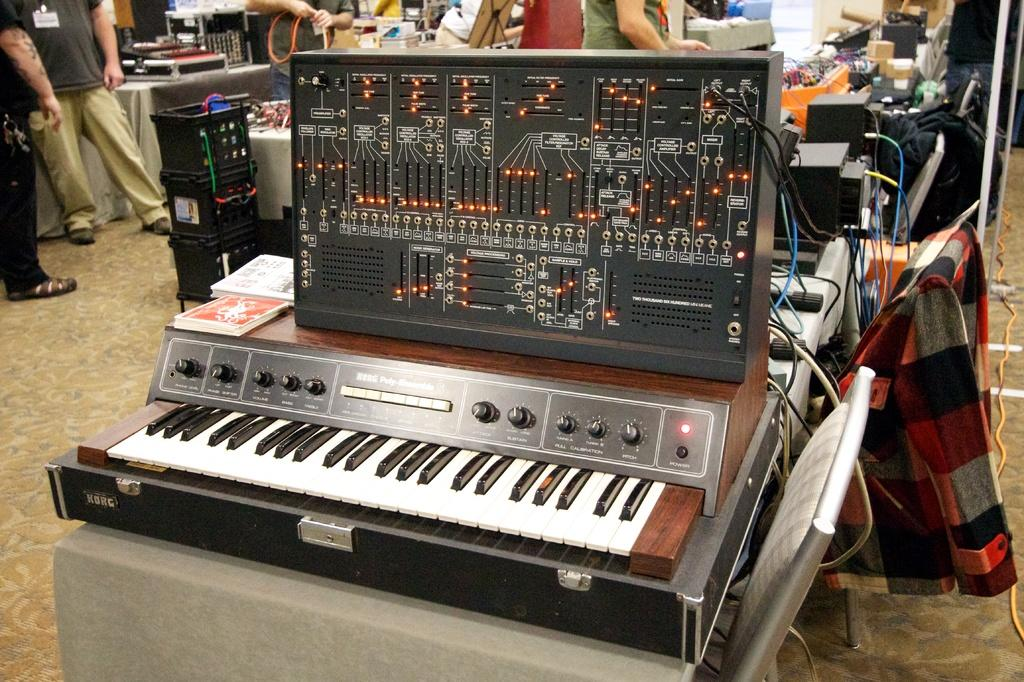What musical instrument is on the table in the image? There is a piano on a table in the image. Can you describe the people in the image? There are people standing at the back side of the image. What type of furniture is present in the image? There are chairs in the image. What reward does the maid receive for cleaning the piano in the image? There is no maid or cleaning activity depicted in the image, so there is no reward to be given. 